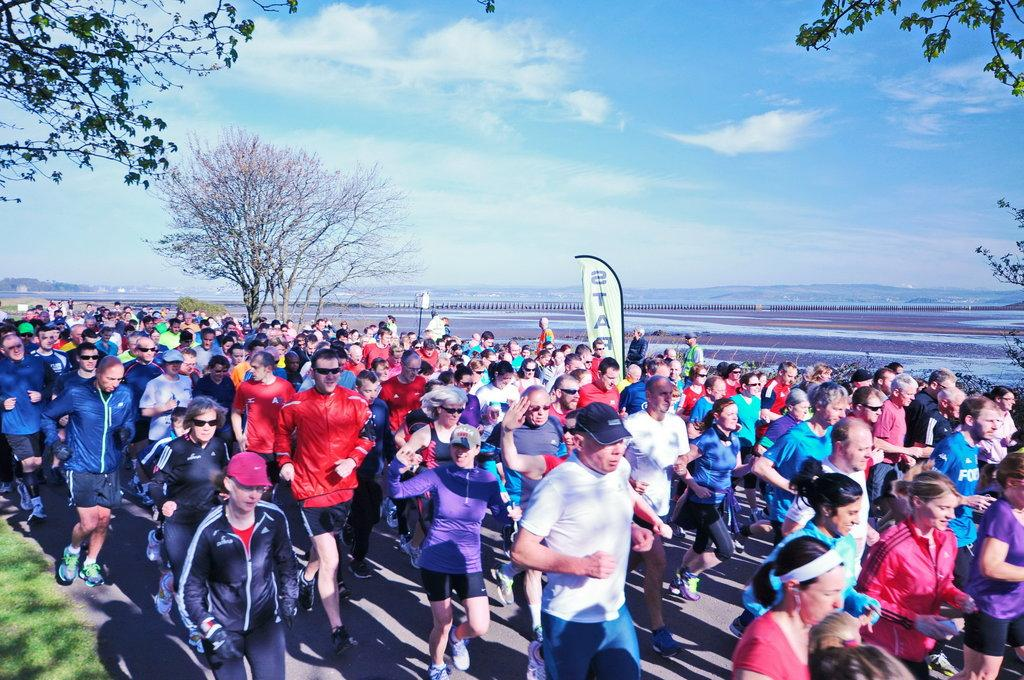How many people are in the image? There is a group of people in the image. What are some of the people doing in the image? Some people are standing, and some are running on the road. What can be seen in the background of the image? There are trees, clouds, and a hoarding visible in the background. What color is the stranger's shirt in the image? There is no stranger present in the image, so we cannot determine the color of their shirt. 